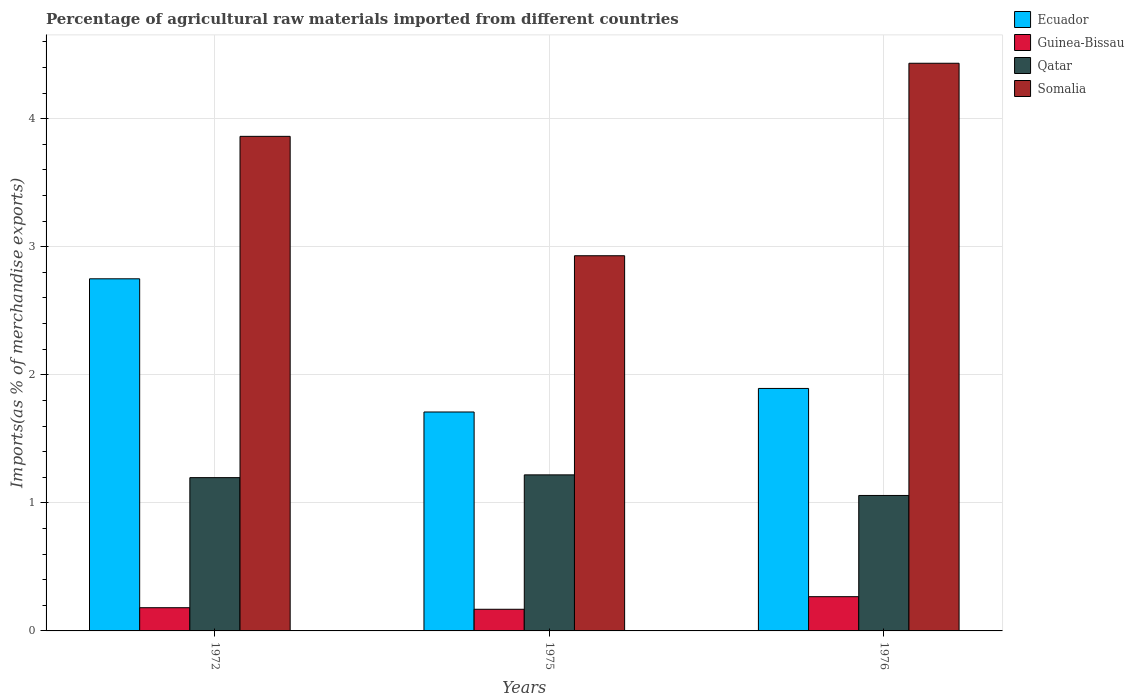Are the number of bars per tick equal to the number of legend labels?
Make the answer very short. Yes. How many bars are there on the 2nd tick from the right?
Offer a terse response. 4. What is the label of the 2nd group of bars from the left?
Keep it short and to the point. 1975. In how many cases, is the number of bars for a given year not equal to the number of legend labels?
Ensure brevity in your answer.  0. What is the percentage of imports to different countries in Ecuador in 1976?
Your answer should be very brief. 1.89. Across all years, what is the maximum percentage of imports to different countries in Somalia?
Give a very brief answer. 4.43. Across all years, what is the minimum percentage of imports to different countries in Somalia?
Make the answer very short. 2.93. In which year was the percentage of imports to different countries in Qatar maximum?
Offer a terse response. 1975. In which year was the percentage of imports to different countries in Qatar minimum?
Provide a short and direct response. 1976. What is the total percentage of imports to different countries in Qatar in the graph?
Your answer should be compact. 3.47. What is the difference between the percentage of imports to different countries in Ecuador in 1972 and that in 1975?
Ensure brevity in your answer.  1.04. What is the difference between the percentage of imports to different countries in Somalia in 1975 and the percentage of imports to different countries in Qatar in 1972?
Your answer should be compact. 1.73. What is the average percentage of imports to different countries in Guinea-Bissau per year?
Ensure brevity in your answer.  0.21. In the year 1975, what is the difference between the percentage of imports to different countries in Somalia and percentage of imports to different countries in Guinea-Bissau?
Offer a very short reply. 2.76. In how many years, is the percentage of imports to different countries in Qatar greater than 3 %?
Your response must be concise. 0. What is the ratio of the percentage of imports to different countries in Guinea-Bissau in 1972 to that in 1976?
Make the answer very short. 0.68. What is the difference between the highest and the second highest percentage of imports to different countries in Ecuador?
Your answer should be compact. 0.86. What is the difference between the highest and the lowest percentage of imports to different countries in Ecuador?
Ensure brevity in your answer.  1.04. Is the sum of the percentage of imports to different countries in Somalia in 1975 and 1976 greater than the maximum percentage of imports to different countries in Qatar across all years?
Give a very brief answer. Yes. Is it the case that in every year, the sum of the percentage of imports to different countries in Ecuador and percentage of imports to different countries in Somalia is greater than the sum of percentage of imports to different countries in Qatar and percentage of imports to different countries in Guinea-Bissau?
Offer a very short reply. Yes. What does the 3rd bar from the left in 1976 represents?
Provide a succinct answer. Qatar. What does the 1st bar from the right in 1976 represents?
Provide a succinct answer. Somalia. Is it the case that in every year, the sum of the percentage of imports to different countries in Ecuador and percentage of imports to different countries in Guinea-Bissau is greater than the percentage of imports to different countries in Somalia?
Your answer should be very brief. No. Are all the bars in the graph horizontal?
Your answer should be very brief. No. What is the difference between two consecutive major ticks on the Y-axis?
Your response must be concise. 1. Are the values on the major ticks of Y-axis written in scientific E-notation?
Keep it short and to the point. No. Does the graph contain any zero values?
Your answer should be very brief. No. Does the graph contain grids?
Give a very brief answer. Yes. Where does the legend appear in the graph?
Provide a short and direct response. Top right. What is the title of the graph?
Provide a succinct answer. Percentage of agricultural raw materials imported from different countries. Does "Rwanda" appear as one of the legend labels in the graph?
Keep it short and to the point. No. What is the label or title of the X-axis?
Keep it short and to the point. Years. What is the label or title of the Y-axis?
Your answer should be very brief. Imports(as % of merchandise exports). What is the Imports(as % of merchandise exports) in Ecuador in 1972?
Provide a short and direct response. 2.75. What is the Imports(as % of merchandise exports) of Guinea-Bissau in 1972?
Your response must be concise. 0.18. What is the Imports(as % of merchandise exports) of Qatar in 1972?
Your answer should be compact. 1.2. What is the Imports(as % of merchandise exports) of Somalia in 1972?
Offer a terse response. 3.86. What is the Imports(as % of merchandise exports) in Ecuador in 1975?
Ensure brevity in your answer.  1.71. What is the Imports(as % of merchandise exports) in Guinea-Bissau in 1975?
Provide a short and direct response. 0.17. What is the Imports(as % of merchandise exports) in Qatar in 1975?
Your response must be concise. 1.22. What is the Imports(as % of merchandise exports) in Somalia in 1975?
Ensure brevity in your answer.  2.93. What is the Imports(as % of merchandise exports) in Ecuador in 1976?
Give a very brief answer. 1.89. What is the Imports(as % of merchandise exports) in Guinea-Bissau in 1976?
Make the answer very short. 0.27. What is the Imports(as % of merchandise exports) in Qatar in 1976?
Ensure brevity in your answer.  1.06. What is the Imports(as % of merchandise exports) in Somalia in 1976?
Keep it short and to the point. 4.43. Across all years, what is the maximum Imports(as % of merchandise exports) of Ecuador?
Provide a succinct answer. 2.75. Across all years, what is the maximum Imports(as % of merchandise exports) in Guinea-Bissau?
Your answer should be very brief. 0.27. Across all years, what is the maximum Imports(as % of merchandise exports) of Qatar?
Offer a very short reply. 1.22. Across all years, what is the maximum Imports(as % of merchandise exports) of Somalia?
Ensure brevity in your answer.  4.43. Across all years, what is the minimum Imports(as % of merchandise exports) in Ecuador?
Make the answer very short. 1.71. Across all years, what is the minimum Imports(as % of merchandise exports) in Guinea-Bissau?
Offer a terse response. 0.17. Across all years, what is the minimum Imports(as % of merchandise exports) of Qatar?
Your answer should be compact. 1.06. Across all years, what is the minimum Imports(as % of merchandise exports) in Somalia?
Offer a terse response. 2.93. What is the total Imports(as % of merchandise exports) of Ecuador in the graph?
Your response must be concise. 6.35. What is the total Imports(as % of merchandise exports) in Guinea-Bissau in the graph?
Provide a succinct answer. 0.62. What is the total Imports(as % of merchandise exports) of Qatar in the graph?
Keep it short and to the point. 3.47. What is the total Imports(as % of merchandise exports) in Somalia in the graph?
Ensure brevity in your answer.  11.22. What is the difference between the Imports(as % of merchandise exports) of Ecuador in 1972 and that in 1975?
Provide a succinct answer. 1.04. What is the difference between the Imports(as % of merchandise exports) in Guinea-Bissau in 1972 and that in 1975?
Provide a short and direct response. 0.01. What is the difference between the Imports(as % of merchandise exports) of Qatar in 1972 and that in 1975?
Give a very brief answer. -0.02. What is the difference between the Imports(as % of merchandise exports) in Somalia in 1972 and that in 1975?
Make the answer very short. 0.93. What is the difference between the Imports(as % of merchandise exports) of Ecuador in 1972 and that in 1976?
Offer a very short reply. 0.86. What is the difference between the Imports(as % of merchandise exports) of Guinea-Bissau in 1972 and that in 1976?
Keep it short and to the point. -0.09. What is the difference between the Imports(as % of merchandise exports) of Qatar in 1972 and that in 1976?
Your response must be concise. 0.14. What is the difference between the Imports(as % of merchandise exports) of Somalia in 1972 and that in 1976?
Ensure brevity in your answer.  -0.57. What is the difference between the Imports(as % of merchandise exports) in Ecuador in 1975 and that in 1976?
Make the answer very short. -0.18. What is the difference between the Imports(as % of merchandise exports) in Guinea-Bissau in 1975 and that in 1976?
Offer a very short reply. -0.1. What is the difference between the Imports(as % of merchandise exports) of Qatar in 1975 and that in 1976?
Give a very brief answer. 0.16. What is the difference between the Imports(as % of merchandise exports) of Somalia in 1975 and that in 1976?
Provide a short and direct response. -1.5. What is the difference between the Imports(as % of merchandise exports) of Ecuador in 1972 and the Imports(as % of merchandise exports) of Guinea-Bissau in 1975?
Provide a short and direct response. 2.58. What is the difference between the Imports(as % of merchandise exports) in Ecuador in 1972 and the Imports(as % of merchandise exports) in Qatar in 1975?
Provide a short and direct response. 1.53. What is the difference between the Imports(as % of merchandise exports) of Ecuador in 1972 and the Imports(as % of merchandise exports) of Somalia in 1975?
Provide a succinct answer. -0.18. What is the difference between the Imports(as % of merchandise exports) of Guinea-Bissau in 1972 and the Imports(as % of merchandise exports) of Qatar in 1975?
Keep it short and to the point. -1.04. What is the difference between the Imports(as % of merchandise exports) in Guinea-Bissau in 1972 and the Imports(as % of merchandise exports) in Somalia in 1975?
Ensure brevity in your answer.  -2.75. What is the difference between the Imports(as % of merchandise exports) of Qatar in 1972 and the Imports(as % of merchandise exports) of Somalia in 1975?
Provide a succinct answer. -1.73. What is the difference between the Imports(as % of merchandise exports) of Ecuador in 1972 and the Imports(as % of merchandise exports) of Guinea-Bissau in 1976?
Your answer should be compact. 2.48. What is the difference between the Imports(as % of merchandise exports) in Ecuador in 1972 and the Imports(as % of merchandise exports) in Qatar in 1976?
Keep it short and to the point. 1.69. What is the difference between the Imports(as % of merchandise exports) in Ecuador in 1972 and the Imports(as % of merchandise exports) in Somalia in 1976?
Offer a terse response. -1.68. What is the difference between the Imports(as % of merchandise exports) of Guinea-Bissau in 1972 and the Imports(as % of merchandise exports) of Qatar in 1976?
Give a very brief answer. -0.88. What is the difference between the Imports(as % of merchandise exports) in Guinea-Bissau in 1972 and the Imports(as % of merchandise exports) in Somalia in 1976?
Your answer should be very brief. -4.25. What is the difference between the Imports(as % of merchandise exports) of Qatar in 1972 and the Imports(as % of merchandise exports) of Somalia in 1976?
Make the answer very short. -3.24. What is the difference between the Imports(as % of merchandise exports) in Ecuador in 1975 and the Imports(as % of merchandise exports) in Guinea-Bissau in 1976?
Provide a short and direct response. 1.44. What is the difference between the Imports(as % of merchandise exports) in Ecuador in 1975 and the Imports(as % of merchandise exports) in Qatar in 1976?
Keep it short and to the point. 0.65. What is the difference between the Imports(as % of merchandise exports) of Ecuador in 1975 and the Imports(as % of merchandise exports) of Somalia in 1976?
Offer a terse response. -2.72. What is the difference between the Imports(as % of merchandise exports) in Guinea-Bissau in 1975 and the Imports(as % of merchandise exports) in Qatar in 1976?
Offer a terse response. -0.89. What is the difference between the Imports(as % of merchandise exports) of Guinea-Bissau in 1975 and the Imports(as % of merchandise exports) of Somalia in 1976?
Make the answer very short. -4.26. What is the difference between the Imports(as % of merchandise exports) of Qatar in 1975 and the Imports(as % of merchandise exports) of Somalia in 1976?
Keep it short and to the point. -3.21. What is the average Imports(as % of merchandise exports) in Ecuador per year?
Your response must be concise. 2.12. What is the average Imports(as % of merchandise exports) in Guinea-Bissau per year?
Offer a terse response. 0.21. What is the average Imports(as % of merchandise exports) of Qatar per year?
Provide a succinct answer. 1.16. What is the average Imports(as % of merchandise exports) in Somalia per year?
Provide a succinct answer. 3.74. In the year 1972, what is the difference between the Imports(as % of merchandise exports) of Ecuador and Imports(as % of merchandise exports) of Guinea-Bissau?
Provide a short and direct response. 2.57. In the year 1972, what is the difference between the Imports(as % of merchandise exports) of Ecuador and Imports(as % of merchandise exports) of Qatar?
Your response must be concise. 1.55. In the year 1972, what is the difference between the Imports(as % of merchandise exports) in Ecuador and Imports(as % of merchandise exports) in Somalia?
Keep it short and to the point. -1.11. In the year 1972, what is the difference between the Imports(as % of merchandise exports) of Guinea-Bissau and Imports(as % of merchandise exports) of Qatar?
Your answer should be compact. -1.02. In the year 1972, what is the difference between the Imports(as % of merchandise exports) in Guinea-Bissau and Imports(as % of merchandise exports) in Somalia?
Provide a short and direct response. -3.68. In the year 1972, what is the difference between the Imports(as % of merchandise exports) of Qatar and Imports(as % of merchandise exports) of Somalia?
Keep it short and to the point. -2.66. In the year 1975, what is the difference between the Imports(as % of merchandise exports) of Ecuador and Imports(as % of merchandise exports) of Guinea-Bissau?
Your answer should be compact. 1.54. In the year 1975, what is the difference between the Imports(as % of merchandise exports) in Ecuador and Imports(as % of merchandise exports) in Qatar?
Your answer should be compact. 0.49. In the year 1975, what is the difference between the Imports(as % of merchandise exports) of Ecuador and Imports(as % of merchandise exports) of Somalia?
Your answer should be very brief. -1.22. In the year 1975, what is the difference between the Imports(as % of merchandise exports) in Guinea-Bissau and Imports(as % of merchandise exports) in Qatar?
Make the answer very short. -1.05. In the year 1975, what is the difference between the Imports(as % of merchandise exports) of Guinea-Bissau and Imports(as % of merchandise exports) of Somalia?
Make the answer very short. -2.76. In the year 1975, what is the difference between the Imports(as % of merchandise exports) in Qatar and Imports(as % of merchandise exports) in Somalia?
Offer a very short reply. -1.71. In the year 1976, what is the difference between the Imports(as % of merchandise exports) of Ecuador and Imports(as % of merchandise exports) of Guinea-Bissau?
Your answer should be very brief. 1.63. In the year 1976, what is the difference between the Imports(as % of merchandise exports) of Ecuador and Imports(as % of merchandise exports) of Qatar?
Give a very brief answer. 0.84. In the year 1976, what is the difference between the Imports(as % of merchandise exports) in Ecuador and Imports(as % of merchandise exports) in Somalia?
Offer a terse response. -2.54. In the year 1976, what is the difference between the Imports(as % of merchandise exports) of Guinea-Bissau and Imports(as % of merchandise exports) of Qatar?
Give a very brief answer. -0.79. In the year 1976, what is the difference between the Imports(as % of merchandise exports) in Guinea-Bissau and Imports(as % of merchandise exports) in Somalia?
Give a very brief answer. -4.17. In the year 1976, what is the difference between the Imports(as % of merchandise exports) in Qatar and Imports(as % of merchandise exports) in Somalia?
Your answer should be compact. -3.37. What is the ratio of the Imports(as % of merchandise exports) in Ecuador in 1972 to that in 1975?
Ensure brevity in your answer.  1.61. What is the ratio of the Imports(as % of merchandise exports) of Guinea-Bissau in 1972 to that in 1975?
Keep it short and to the point. 1.07. What is the ratio of the Imports(as % of merchandise exports) of Qatar in 1972 to that in 1975?
Make the answer very short. 0.98. What is the ratio of the Imports(as % of merchandise exports) of Somalia in 1972 to that in 1975?
Provide a short and direct response. 1.32. What is the ratio of the Imports(as % of merchandise exports) in Ecuador in 1972 to that in 1976?
Keep it short and to the point. 1.45. What is the ratio of the Imports(as % of merchandise exports) of Guinea-Bissau in 1972 to that in 1976?
Your answer should be compact. 0.68. What is the ratio of the Imports(as % of merchandise exports) in Qatar in 1972 to that in 1976?
Make the answer very short. 1.13. What is the ratio of the Imports(as % of merchandise exports) of Somalia in 1972 to that in 1976?
Make the answer very short. 0.87. What is the ratio of the Imports(as % of merchandise exports) of Ecuador in 1975 to that in 1976?
Your response must be concise. 0.9. What is the ratio of the Imports(as % of merchandise exports) in Guinea-Bissau in 1975 to that in 1976?
Your answer should be compact. 0.63. What is the ratio of the Imports(as % of merchandise exports) in Qatar in 1975 to that in 1976?
Keep it short and to the point. 1.15. What is the ratio of the Imports(as % of merchandise exports) in Somalia in 1975 to that in 1976?
Your response must be concise. 0.66. What is the difference between the highest and the second highest Imports(as % of merchandise exports) of Ecuador?
Provide a short and direct response. 0.86. What is the difference between the highest and the second highest Imports(as % of merchandise exports) in Guinea-Bissau?
Make the answer very short. 0.09. What is the difference between the highest and the second highest Imports(as % of merchandise exports) of Qatar?
Give a very brief answer. 0.02. What is the difference between the highest and the second highest Imports(as % of merchandise exports) in Somalia?
Provide a short and direct response. 0.57. What is the difference between the highest and the lowest Imports(as % of merchandise exports) in Ecuador?
Give a very brief answer. 1.04. What is the difference between the highest and the lowest Imports(as % of merchandise exports) in Guinea-Bissau?
Offer a very short reply. 0.1. What is the difference between the highest and the lowest Imports(as % of merchandise exports) of Qatar?
Offer a terse response. 0.16. What is the difference between the highest and the lowest Imports(as % of merchandise exports) in Somalia?
Offer a very short reply. 1.5. 